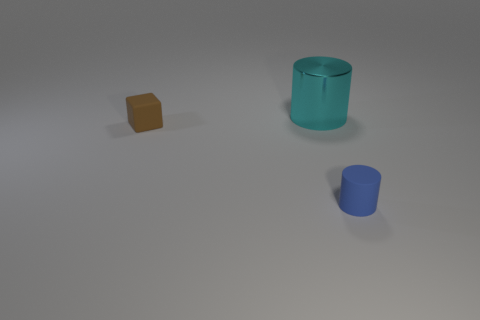Are there any cylinders of the same color as the big thing?
Your answer should be very brief. No. Is the number of metallic cylinders in front of the big cyan metallic thing greater than the number of large green shiny spheres?
Your answer should be very brief. No. Do the cyan thing and the thing to the left of the cyan metal thing have the same shape?
Give a very brief answer. No. Are there any cylinders?
Provide a succinct answer. Yes. What number of small things are blue cylinders or yellow shiny balls?
Make the answer very short. 1. Is the number of small brown cubes on the left side of the small rubber block greater than the number of large cyan metallic cylinders that are in front of the tiny blue rubber thing?
Ensure brevity in your answer.  No. Is the large cyan object made of the same material as the tiny object on the left side of the blue cylinder?
Your response must be concise. No. The large shiny cylinder has what color?
Give a very brief answer. Cyan. There is a tiny thing that is right of the large cylinder; what shape is it?
Keep it short and to the point. Cylinder. What number of brown things are blocks or small matte things?
Give a very brief answer. 1. 